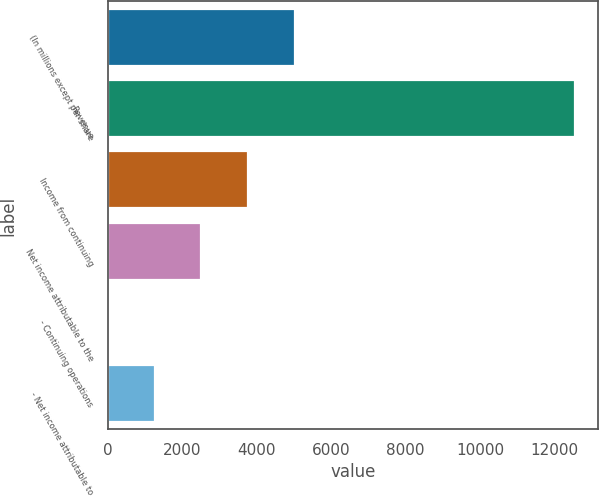<chart> <loc_0><loc_0><loc_500><loc_500><bar_chart><fcel>(In millions except per share<fcel>Revenue<fcel>Income from continuing<fcel>Net income attributable to the<fcel>- Continuing operations<fcel>- Net income attributable to<nl><fcel>5021.49<fcel>12550<fcel>3766.74<fcel>2511.99<fcel>2.49<fcel>1257.24<nl></chart> 